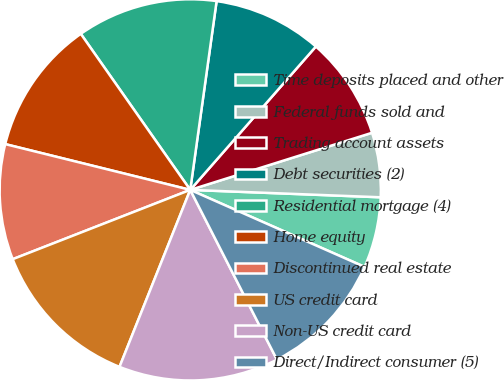Convert chart. <chart><loc_0><loc_0><loc_500><loc_500><pie_chart><fcel>Time deposits placed and other<fcel>Federal funds sold and<fcel>Trading account assets<fcel>Debt securities (2)<fcel>Residential mortgage (4)<fcel>Home equity<fcel>Discontinued real estate<fcel>US credit card<fcel>Non-US credit card<fcel>Direct/Indirect consumer (5)<nl><fcel>6.0%<fcel>5.46%<fcel>8.7%<fcel>9.24%<fcel>11.94%<fcel>11.4%<fcel>9.78%<fcel>13.02%<fcel>13.56%<fcel>10.86%<nl></chart> 